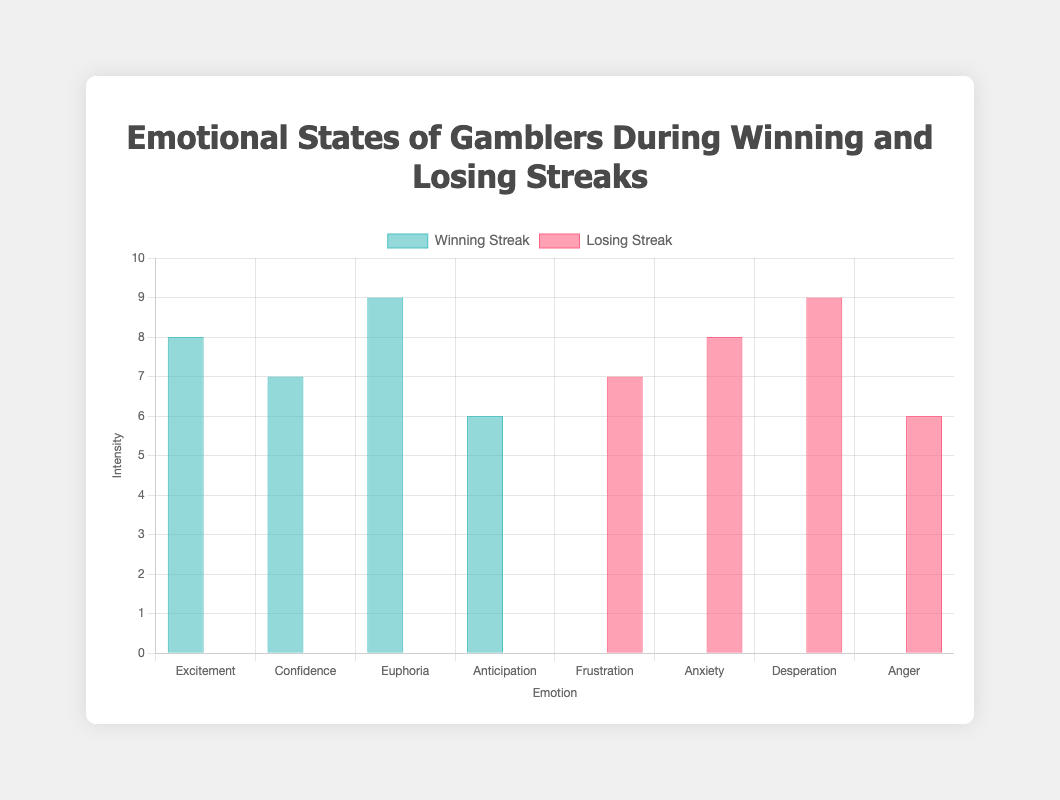What are the highest intensity emotions for winning and losing streaks? The highest intensity emotion during a winning streak is 'Euphoria' with an intensity of 9 🤩. For a losing streak, it is 'Desperation,' also with an intensity of 9 😩.
Answer: Euphoria (9 🤩), Desperation (9 😩) Which emotion has the least intensity during a winning streak? Among the winning streak emotions, 'Anticipation' has the least intensity with a value of 6 😃.
Answer: Anticipation (6 😃) How does the intensity of 'Frustration' during a losing streak compare to 'Confidence' during a winning streak? 'Frustration' has an intensity of 7 😤 during a losing streak, and 'Confidence' has an intensity of 7 😎 during a winning streak. Both emotions have the same intensity.
Answer: Same intensity (7 😤, 7 😎) What is the average intensity of emotions during a winning streak? The intensities are: Excitement (8), Confidence (7), Euphoria (9), Anticipation (6). So, the average is (8+7+9+6)/4 = 7.5.
Answer: 7.5 Which emotion is represented by 😠, and what is its intensity? The emoji 😠 represents 'Anger' during a losing streak, with an intensity of 6.
Answer: Anger (6 😠) Compare the intensity of 'Excitement' during a winning streak to 'Anxiety' during a losing streak. 'Excitement' has an intensity of 8 😀, while 'Anxiety' has an intensity of 8 😰. Both emotions have the same intensity.
Answer: Same intensity (8 😀, 8 😰) What is the difference in intensity between the highest and lowest emotions in a winning streak? The highest is 'Euphoria' (9 🤩) and the lowest is 'Anticipation' (6 😃). The difference is 9 - 6 = 3.
Answer: 3 Which emotions are experienced during a losing streak, and what are their intensities? The emotions with their intensities are 'Frustration' (7 😤), 'Anxiety' (8 😰), 'Desperation' (9 😩), and 'Anger' (6 😠).
Answer: Frustration (7 😤), Anxiety (8 😰), Desperation (9 😩), Anger (6 😠) What is the total intensity of all emotions during a losing streak? The intensities are 'Frustration' (7), 'Anxiety' (8), 'Desperation' (9), and 'Anger' (6). The total is 7 + 8 + 9 + 6 = 30.
Answer: 30 How does 'Anticipation' during a winning streak compare to 'Anger' during a losing streak? 'Anticipation' has an intensity of 6 😃 and 'Anger' has an intensity of 6 😠. Both have the same intensity.
Answer: Same intensity (6 😃, 6 😠) 